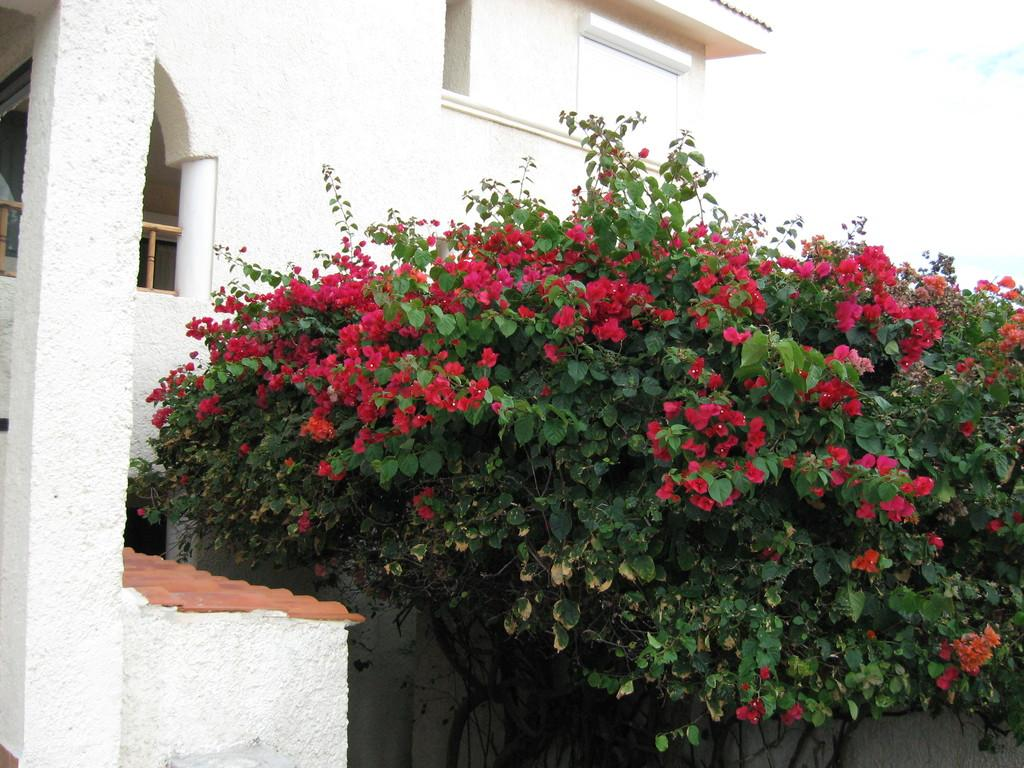What type of living organism can be seen in the image? There is a plant in the image. What specific feature of the plant is visible? The plant has flowers. What can be seen in the background of the image? There is a building in the background of the image. Where is the baby located in the image? There is no baby present in the image. What type of vegetable is growing next to the plant in the image? There is no vegetable present in the image; only the plant with flowers is visible. 